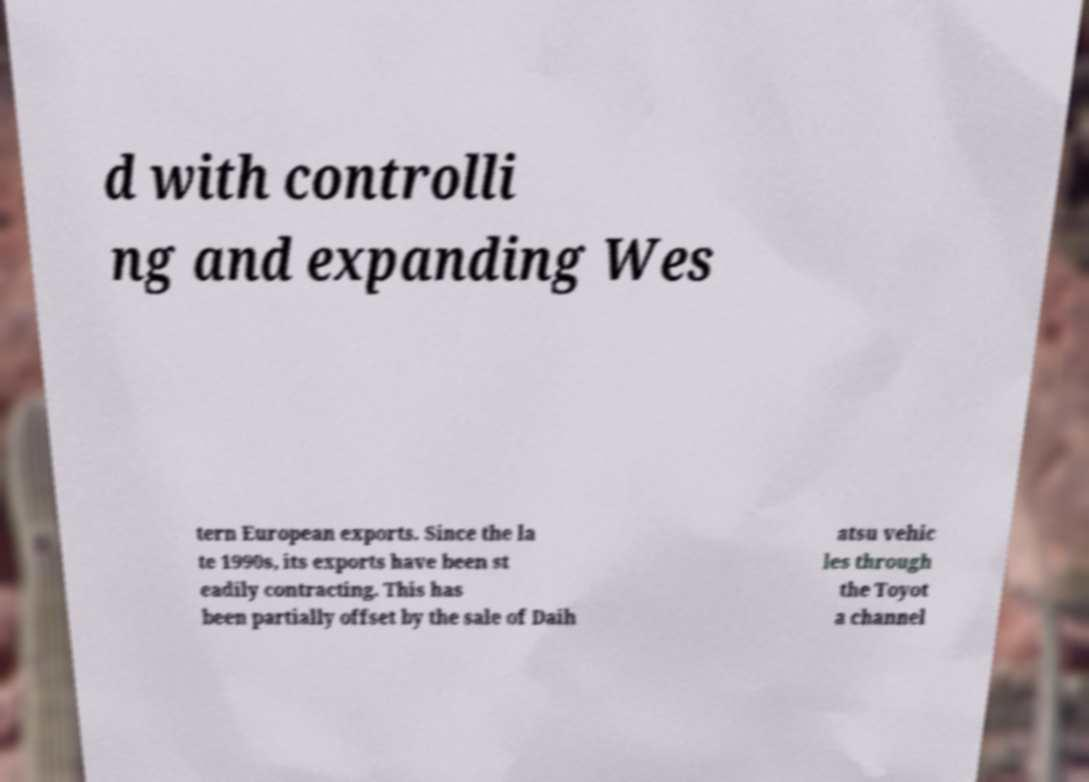Could you extract and type out the text from this image? d with controlli ng and expanding Wes tern European exports. Since the la te 1990s, its exports have been st eadily contracting. This has been partially offset by the sale of Daih atsu vehic les through the Toyot a channel 